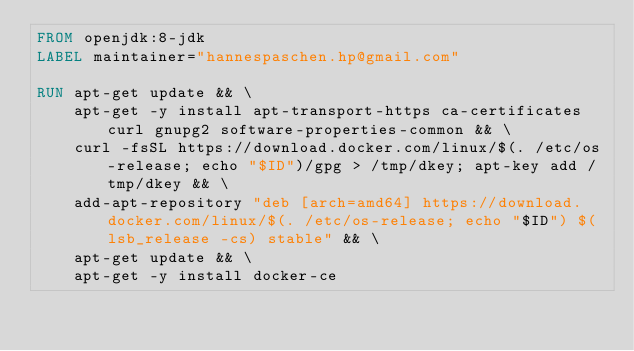Convert code to text. <code><loc_0><loc_0><loc_500><loc_500><_Dockerfile_>FROM openjdk:8-jdk
LABEL maintainer="hannespaschen.hp@gmail.com"

RUN apt-get update && \
    apt-get -y install apt-transport-https ca-certificates curl gnupg2 software-properties-common && \
    curl -fsSL https://download.docker.com/linux/$(. /etc/os-release; echo "$ID")/gpg > /tmp/dkey; apt-key add /tmp/dkey && \
    add-apt-repository "deb [arch=amd64] https://download.docker.com/linux/$(. /etc/os-release; echo "$ID") $(lsb_release -cs) stable" && \
    apt-get update && \
    apt-get -y install docker-ce
</code> 